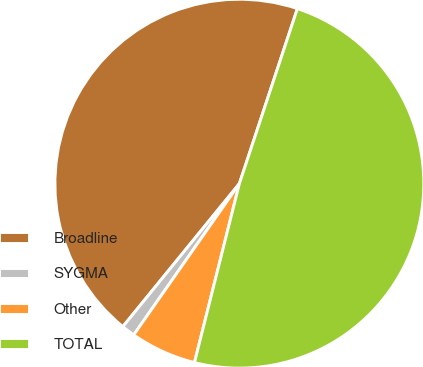Convert chart. <chart><loc_0><loc_0><loc_500><loc_500><pie_chart><fcel>Broadline<fcel>SYGMA<fcel>Other<fcel>TOTAL<nl><fcel>44.21%<fcel>1.18%<fcel>5.79%<fcel>48.82%<nl></chart> 